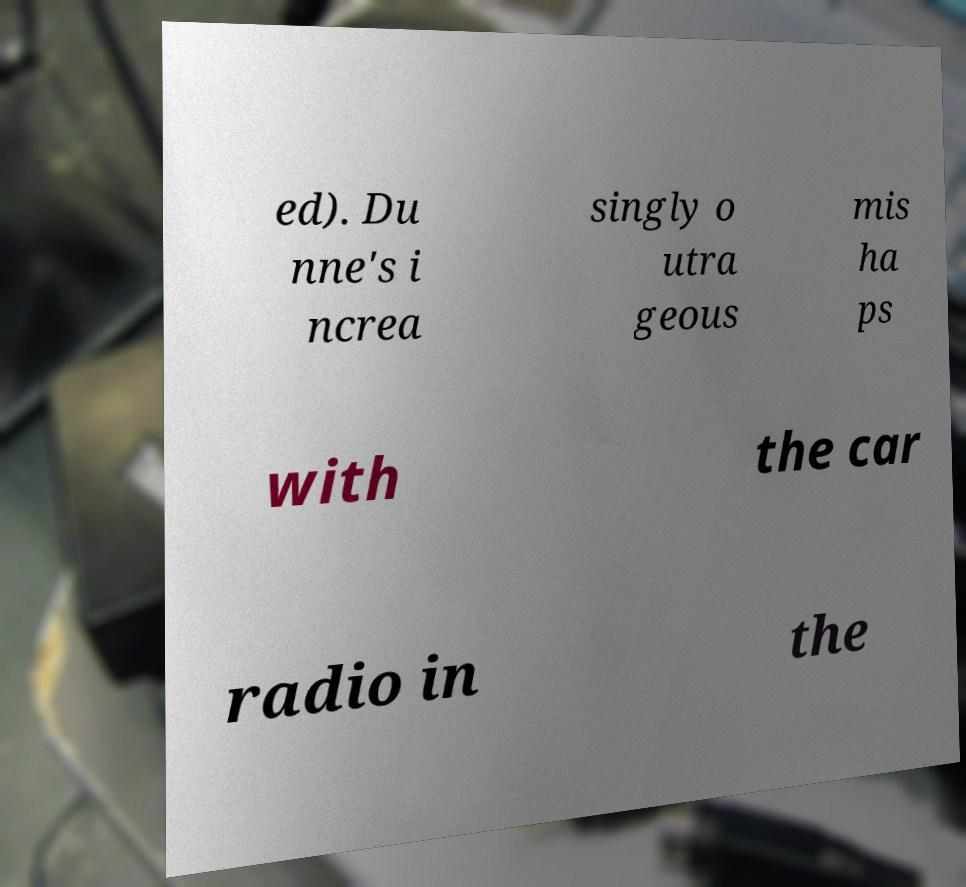There's text embedded in this image that I need extracted. Can you transcribe it verbatim? ed). Du nne's i ncrea singly o utra geous mis ha ps with the car radio in the 